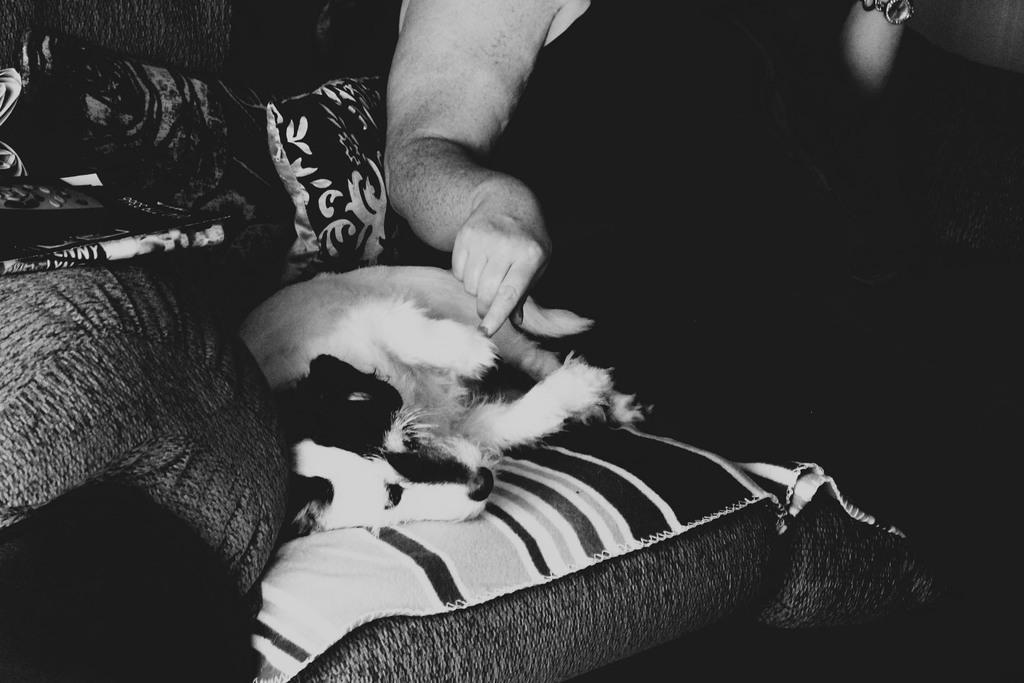What is the person in the image doing? There is a person sitting on the sofa in the image. Is there any other living creature in the image? Yes, there is a dog beside the person. What type of furniture is the person sitting on? The person is sitting on a sofa. Are there any additional items visible in the image? Yes, there are pillows in the image. What type of ring can be seen on the dog's collar in the image? There is no ring mentioned or visible on the dog's collar in the image. How many apples are on the table in the image? There is no table or apples present in the image. 